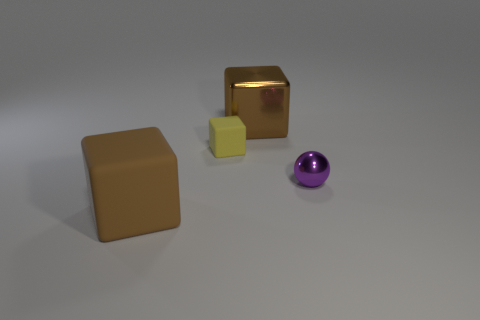The small matte thing has what color?
Keep it short and to the point. Yellow. What color is the tiny rubber thing that is the same shape as the large brown metallic object?
Your answer should be very brief. Yellow. How many yellow rubber objects have the same shape as the brown matte object?
Keep it short and to the point. 1. What number of things are big gray metal cubes or objects that are behind the brown rubber block?
Make the answer very short. 3. Does the metallic block have the same color as the cube that is in front of the small ball?
Provide a short and direct response. Yes. There is a thing that is on the right side of the small rubber thing and in front of the tiny yellow object; how big is it?
Make the answer very short. Small. Are there any brown metal things to the right of the small metal sphere?
Provide a short and direct response. No. There is a brown thing that is in front of the large shiny thing; are there any large cubes that are left of it?
Keep it short and to the point. No. Is the number of things in front of the purple object the same as the number of big brown objects that are on the left side of the tiny cube?
Give a very brief answer. Yes. The large object that is made of the same material as the small ball is what color?
Keep it short and to the point. Brown. 